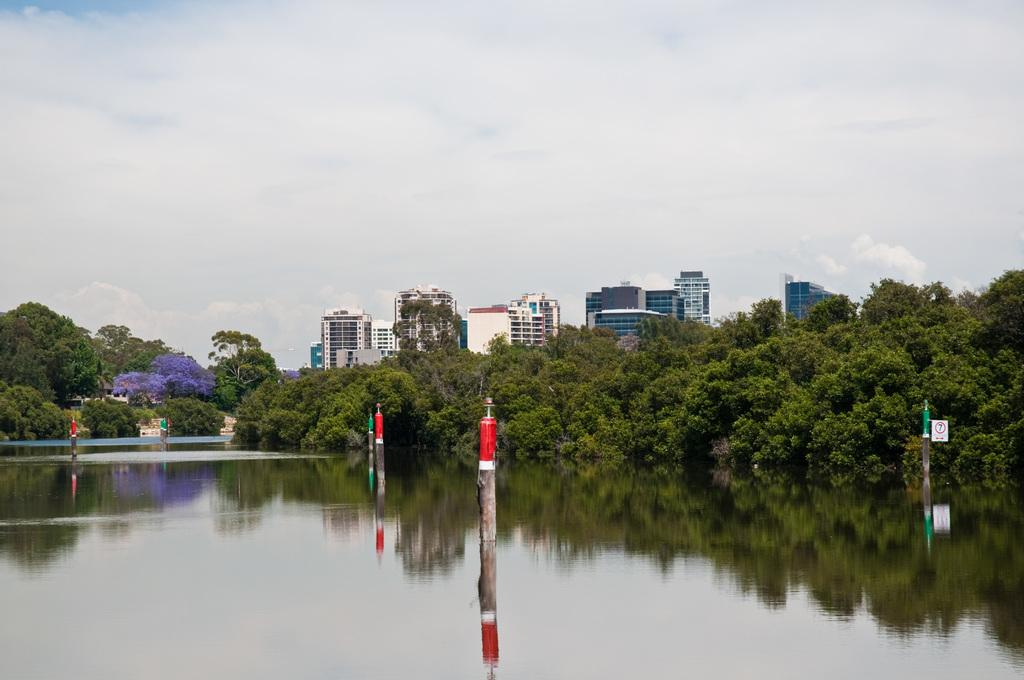What type of structures can be seen in the image? There are buildings in the image. What type of vegetation is present in the image? There are trees in the image. What other objects can be seen in the image? There are boards and poles in the image. What is visible at the top of the image? The sky is visible at the top of the image. What is visible at the bottom of the image? There is water visible at the bottom of the image. What type of coast can be seen in the image? There is no coast present in the image. Is there a map of the area in the image? There is no map present in the image. 